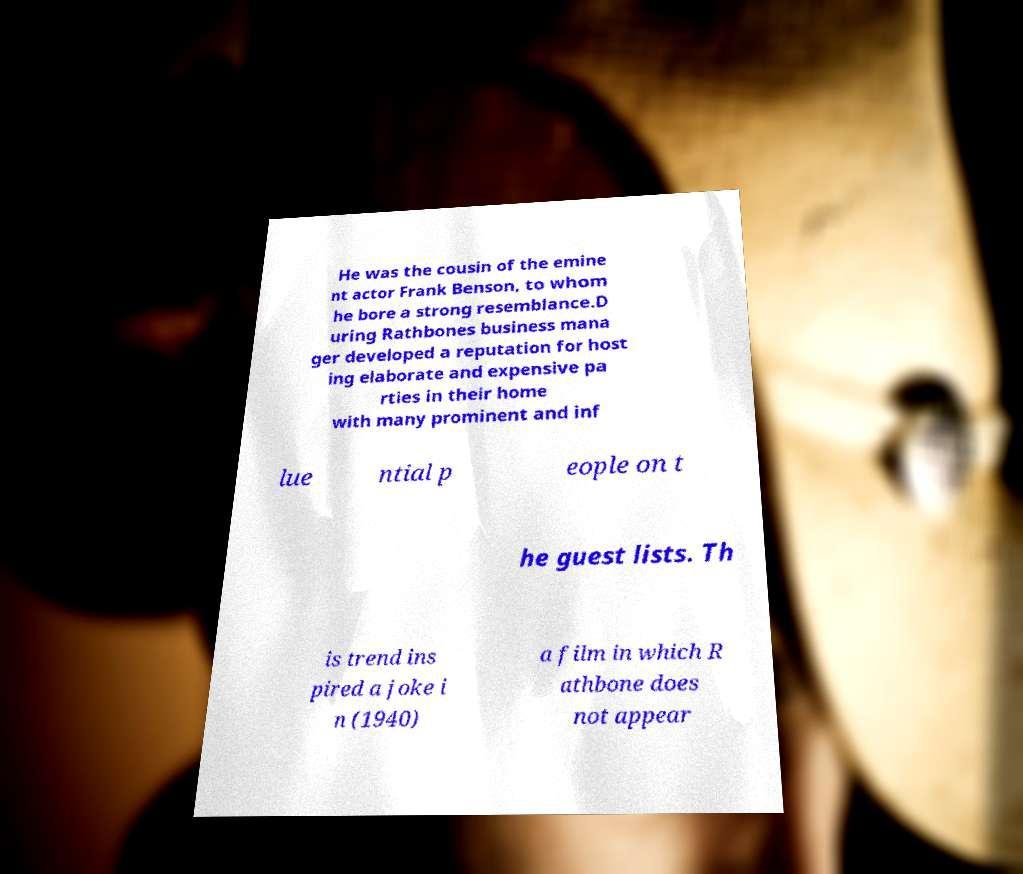Could you extract and type out the text from this image? He was the cousin of the emine nt actor Frank Benson, to whom he bore a strong resemblance.D uring Rathbones business mana ger developed a reputation for host ing elaborate and expensive pa rties in their home with many prominent and inf lue ntial p eople on t he guest lists. Th is trend ins pired a joke i n (1940) a film in which R athbone does not appear 